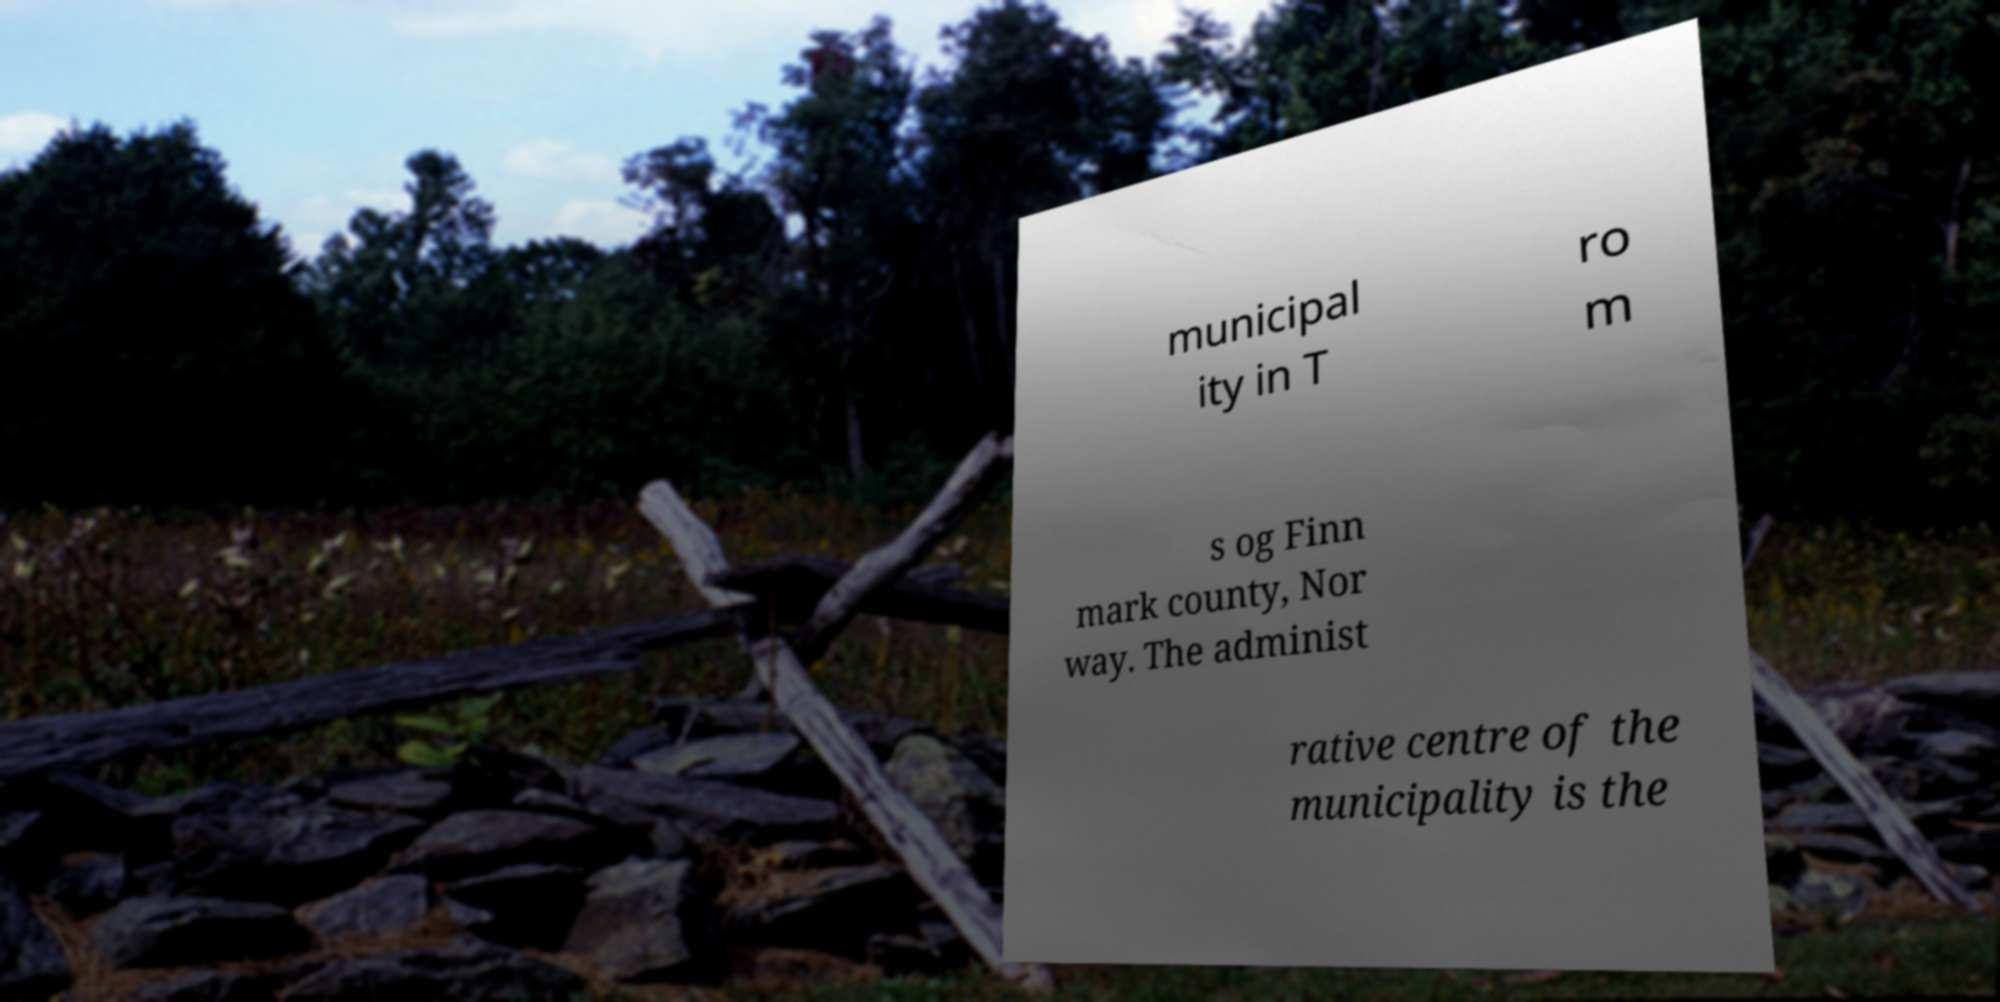Could you assist in decoding the text presented in this image and type it out clearly? municipal ity in T ro m s og Finn mark county, Nor way. The administ rative centre of the municipality is the 